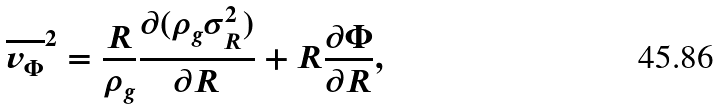<formula> <loc_0><loc_0><loc_500><loc_500>\overline { v _ { \Phi } } ^ { 2 } = \frac { R } { \rho _ { g } } \frac { \partial ( \rho _ { g } \sigma _ { R } ^ { 2 } ) } { \partial R } + R \frac { \partial \Phi } { \partial R } ,</formula> 